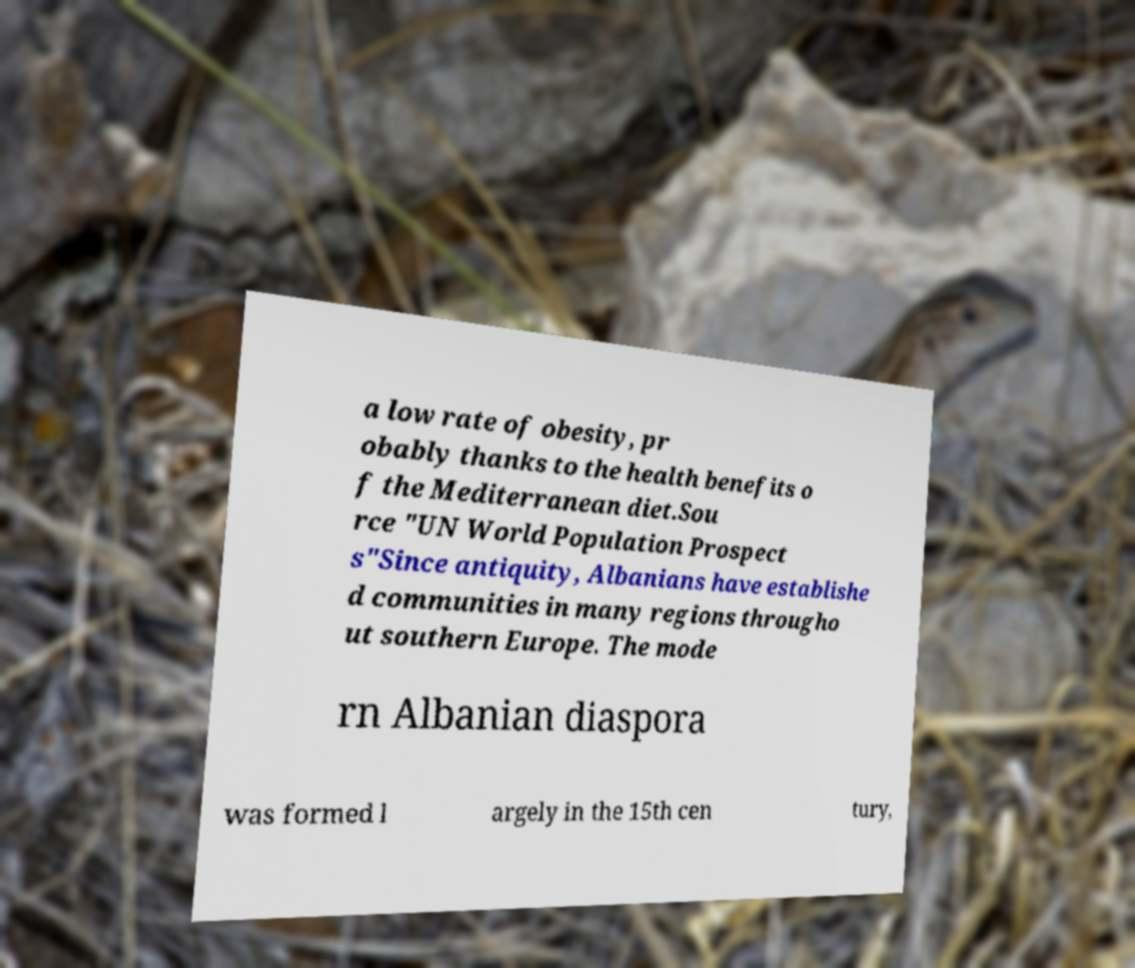For documentation purposes, I need the text within this image transcribed. Could you provide that? a low rate of obesity, pr obably thanks to the health benefits o f the Mediterranean diet.Sou rce "UN World Population Prospect s"Since antiquity, Albanians have establishe d communities in many regions througho ut southern Europe. The mode rn Albanian diaspora was formed l argely in the 15th cen tury, 